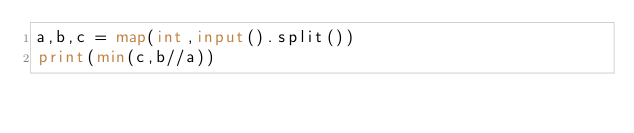<code> <loc_0><loc_0><loc_500><loc_500><_Python_>a,b,c = map(int,input().split())
print(min(c,b//a))</code> 